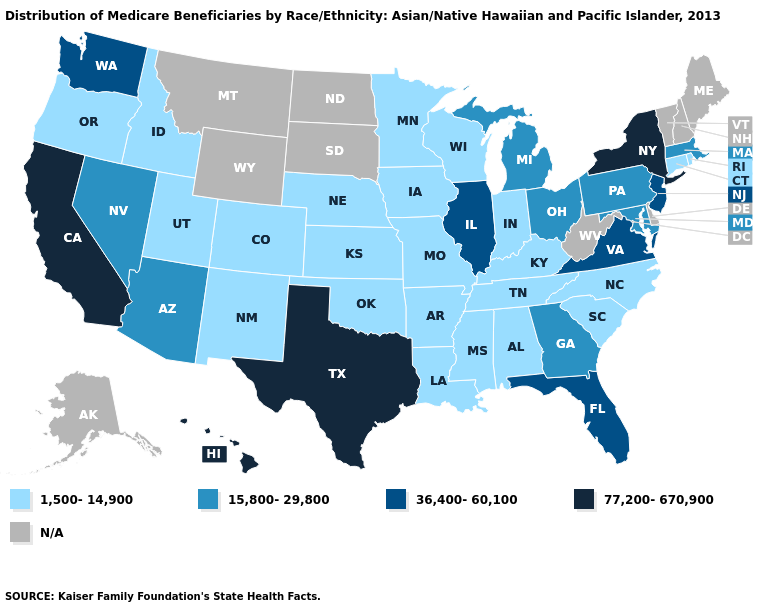Among the states that border Missouri , which have the highest value?
Answer briefly. Illinois. Name the states that have a value in the range 77,200-670,900?
Give a very brief answer. California, Hawaii, New York, Texas. Which states have the lowest value in the West?
Write a very short answer. Colorado, Idaho, New Mexico, Oregon, Utah. Name the states that have a value in the range 15,800-29,800?
Quick response, please. Arizona, Georgia, Maryland, Massachusetts, Michigan, Nevada, Ohio, Pennsylvania. What is the value of Kentucky?
Keep it brief. 1,500-14,900. Name the states that have a value in the range 1,500-14,900?
Short answer required. Alabama, Arkansas, Colorado, Connecticut, Idaho, Indiana, Iowa, Kansas, Kentucky, Louisiana, Minnesota, Mississippi, Missouri, Nebraska, New Mexico, North Carolina, Oklahoma, Oregon, Rhode Island, South Carolina, Tennessee, Utah, Wisconsin. Which states have the lowest value in the USA?
Answer briefly. Alabama, Arkansas, Colorado, Connecticut, Idaho, Indiana, Iowa, Kansas, Kentucky, Louisiana, Minnesota, Mississippi, Missouri, Nebraska, New Mexico, North Carolina, Oklahoma, Oregon, Rhode Island, South Carolina, Tennessee, Utah, Wisconsin. What is the highest value in the Northeast ?
Quick response, please. 77,200-670,900. Among the states that border New Jersey , which have the highest value?
Short answer required. New York. Name the states that have a value in the range 15,800-29,800?
Quick response, please. Arizona, Georgia, Maryland, Massachusetts, Michigan, Nevada, Ohio, Pennsylvania. What is the value of Illinois?
Be succinct. 36,400-60,100. What is the value of Montana?
Short answer required. N/A. Which states hav the highest value in the Northeast?
Answer briefly. New York. Among the states that border Florida , does Alabama have the highest value?
Answer briefly. No. 